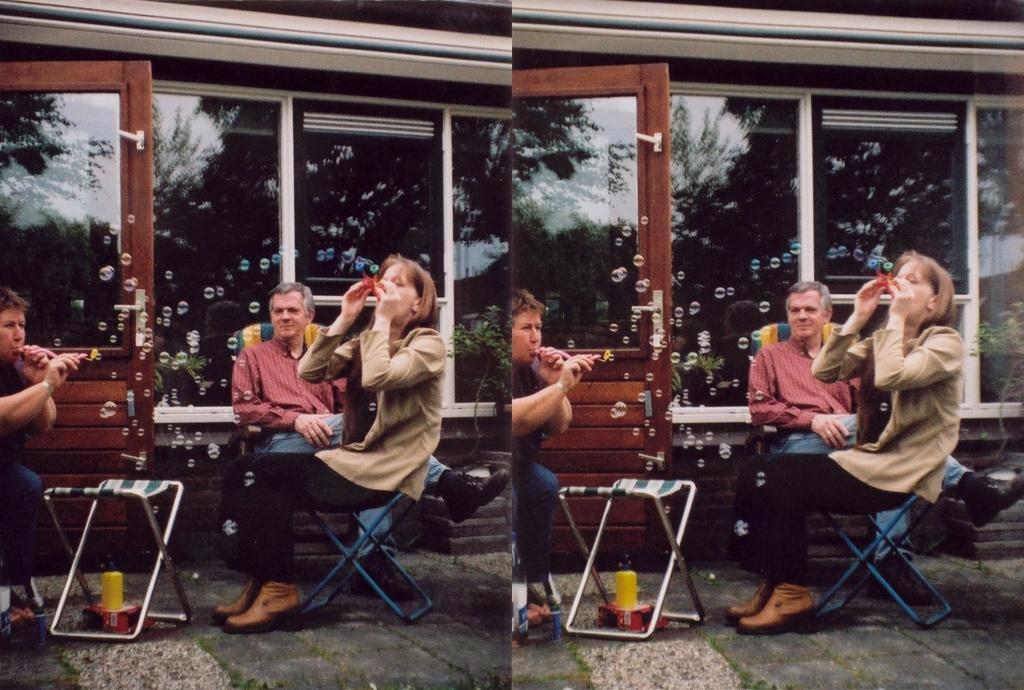How would you summarize this image in a sentence or two? This is an edited image. In this picture, we see the two images which are same. Here, we see three people are sitting on the chairs and they might be eating. In front of them, we see a stool under which a yellow and red color boxes are placed. Behind them, we see the glass doors and windows from which we can see the trees. 